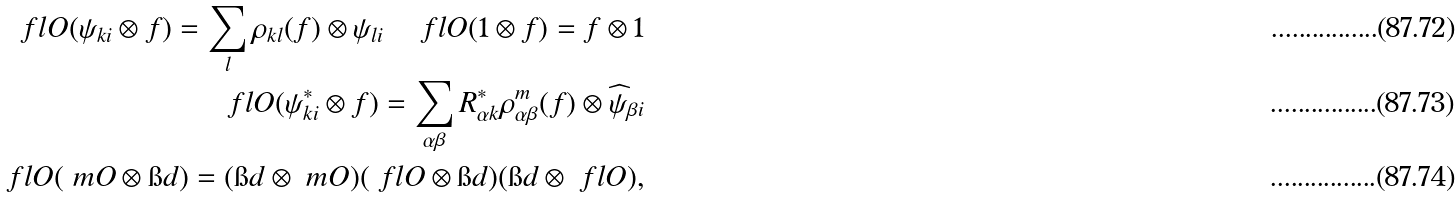Convert formula to latex. <formula><loc_0><loc_0><loc_500><loc_500>\ f l O ( \psi _ { k i } \otimes f ) = \sum _ { l } \rho _ { k l } ( f ) \otimes \psi _ { l i } \quad \ f l O ( 1 \otimes f ) = f \otimes 1 \\ \ f l O ( \psi _ { k i } ^ { * } \otimes f ) = \sum _ { \alpha \beta } R ^ { * } _ { \alpha k } \rho ^ { m } _ { \alpha \beta } ( f ) \otimes \widehat { \psi } _ { \beta i } \\ \ f l O ( \ m O \otimes \i d ) = ( \i d \otimes \ m O ) ( \ f l O \otimes \i d ) ( \i d \otimes \ f l O ) ,</formula> 